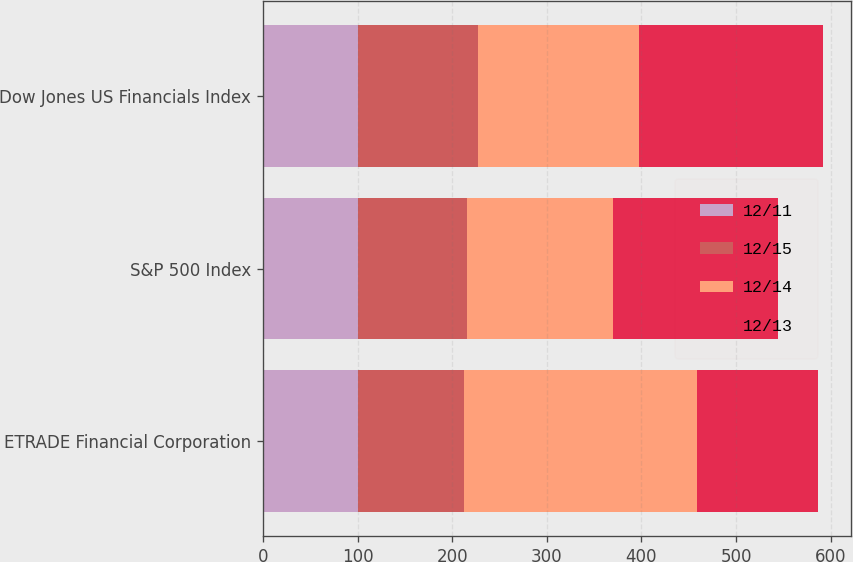Convert chart to OTSL. <chart><loc_0><loc_0><loc_500><loc_500><stacked_bar_chart><ecel><fcel>ETRADE Financial Corporation<fcel>S&P 500 Index<fcel>Dow Jones US Financials Index<nl><fcel>12/11<fcel>100<fcel>100<fcel>100<nl><fcel>12/15<fcel>112.44<fcel>116<fcel>126.85<nl><fcel>12/14<fcel>246.73<fcel>153.58<fcel>170.26<nl><fcel>12/13<fcel>126.85<fcel>174.6<fcel>195.1<nl></chart> 